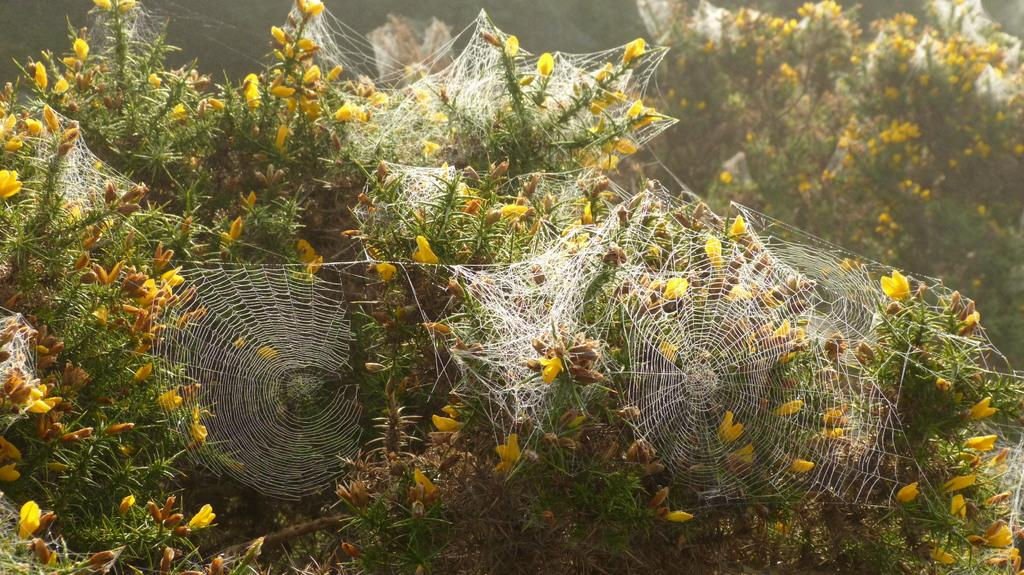What type of webs can be seen on the plants in the image? There are spider nets on the plants in the image. How many spider nets are visible on the plants? The number of spider nets cannot be determined from the image, but there are at least a few visible on the plants. What type of clover is growing in the image? There is no clover present in the image; it features spider nets on plants. 